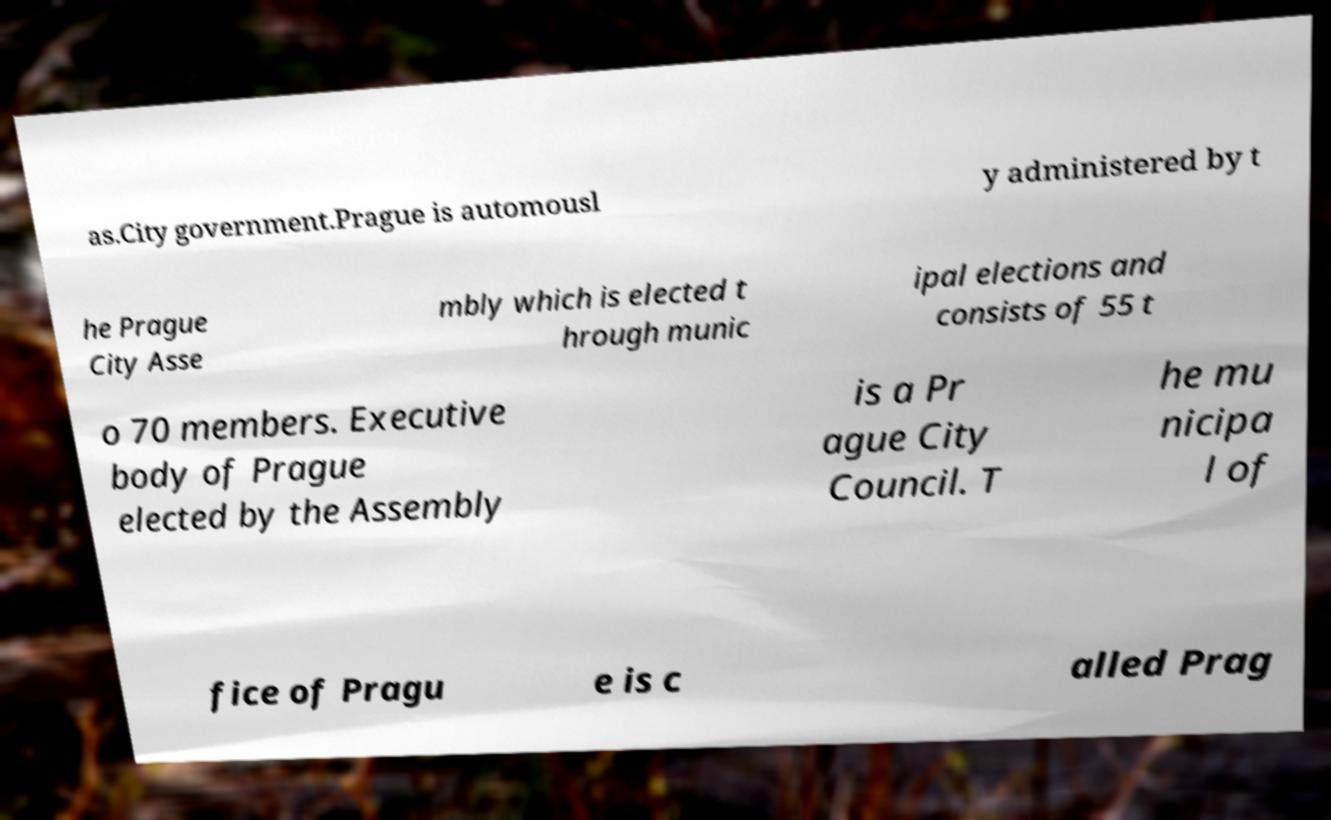For documentation purposes, I need the text within this image transcribed. Could you provide that? as.City government.Prague is automousl y administered by t he Prague City Asse mbly which is elected t hrough munic ipal elections and consists of 55 t o 70 members. Executive body of Prague elected by the Assembly is a Pr ague City Council. T he mu nicipa l of fice of Pragu e is c alled Prag 